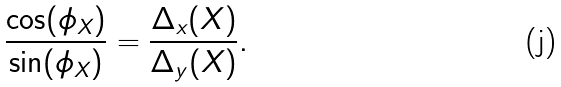<formula> <loc_0><loc_0><loc_500><loc_500>\frac { \cos ( \phi _ { X } ) } { \sin ( \phi _ { X } ) } = \frac { \Delta _ { x } ( X ) } { \Delta _ { y } ( X ) } .</formula> 